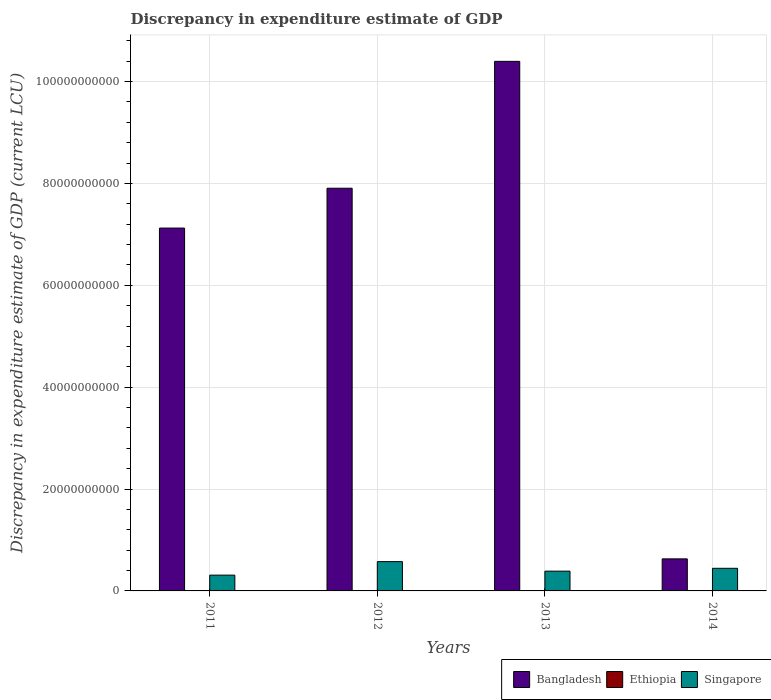How many different coloured bars are there?
Give a very brief answer. 3. How many groups of bars are there?
Make the answer very short. 4. Are the number of bars per tick equal to the number of legend labels?
Provide a short and direct response. No. Are the number of bars on each tick of the X-axis equal?
Provide a succinct answer. No. How many bars are there on the 2nd tick from the right?
Your answer should be compact. 2. What is the discrepancy in expenditure estimate of GDP in Bangladesh in 2012?
Give a very brief answer. 7.91e+1. Across all years, what is the maximum discrepancy in expenditure estimate of GDP in Singapore?
Offer a very short reply. 5.75e+09. Across all years, what is the minimum discrepancy in expenditure estimate of GDP in Bangladesh?
Provide a short and direct response. 6.29e+09. In which year was the discrepancy in expenditure estimate of GDP in Ethiopia maximum?
Make the answer very short. 2012. What is the total discrepancy in expenditure estimate of GDP in Bangladesh in the graph?
Ensure brevity in your answer.  2.61e+11. What is the difference between the discrepancy in expenditure estimate of GDP in Singapore in 2011 and that in 2013?
Make the answer very short. -7.83e+08. What is the difference between the discrepancy in expenditure estimate of GDP in Singapore in 2011 and the discrepancy in expenditure estimate of GDP in Bangladesh in 2014?
Offer a very short reply. -3.19e+09. What is the average discrepancy in expenditure estimate of GDP in Bangladesh per year?
Your answer should be compact. 6.51e+1. In the year 2013, what is the difference between the discrepancy in expenditure estimate of GDP in Bangladesh and discrepancy in expenditure estimate of GDP in Singapore?
Provide a short and direct response. 1.00e+11. In how many years, is the discrepancy in expenditure estimate of GDP in Ethiopia greater than 80000000000 LCU?
Offer a very short reply. 0. What is the ratio of the discrepancy in expenditure estimate of GDP in Bangladesh in 2011 to that in 2014?
Ensure brevity in your answer.  11.32. What is the difference between the highest and the second highest discrepancy in expenditure estimate of GDP in Singapore?
Your answer should be very brief. 1.31e+09. What is the difference between the highest and the lowest discrepancy in expenditure estimate of GDP in Singapore?
Ensure brevity in your answer.  2.65e+09. In how many years, is the discrepancy in expenditure estimate of GDP in Ethiopia greater than the average discrepancy in expenditure estimate of GDP in Ethiopia taken over all years?
Ensure brevity in your answer.  1. Is the sum of the discrepancy in expenditure estimate of GDP in Singapore in 2012 and 2013 greater than the maximum discrepancy in expenditure estimate of GDP in Ethiopia across all years?
Keep it short and to the point. Yes. How many years are there in the graph?
Provide a succinct answer. 4. Are the values on the major ticks of Y-axis written in scientific E-notation?
Offer a very short reply. No. Does the graph contain grids?
Provide a succinct answer. Yes. Where does the legend appear in the graph?
Make the answer very short. Bottom right. How are the legend labels stacked?
Your response must be concise. Horizontal. What is the title of the graph?
Provide a succinct answer. Discrepancy in expenditure estimate of GDP. Does "Algeria" appear as one of the legend labels in the graph?
Make the answer very short. No. What is the label or title of the Y-axis?
Your answer should be compact. Discrepancy in expenditure estimate of GDP (current LCU). What is the Discrepancy in expenditure estimate of GDP (current LCU) in Bangladesh in 2011?
Your answer should be very brief. 7.12e+1. What is the Discrepancy in expenditure estimate of GDP (current LCU) in Ethiopia in 2011?
Your answer should be compact. 0. What is the Discrepancy in expenditure estimate of GDP (current LCU) of Singapore in 2011?
Provide a short and direct response. 3.10e+09. What is the Discrepancy in expenditure estimate of GDP (current LCU) of Bangladesh in 2012?
Offer a very short reply. 7.91e+1. What is the Discrepancy in expenditure estimate of GDP (current LCU) of Ethiopia in 2012?
Offer a very short reply. 9.49e+04. What is the Discrepancy in expenditure estimate of GDP (current LCU) in Singapore in 2012?
Provide a succinct answer. 5.75e+09. What is the Discrepancy in expenditure estimate of GDP (current LCU) in Bangladesh in 2013?
Provide a short and direct response. 1.04e+11. What is the Discrepancy in expenditure estimate of GDP (current LCU) in Ethiopia in 2013?
Provide a short and direct response. 0. What is the Discrepancy in expenditure estimate of GDP (current LCU) in Singapore in 2013?
Ensure brevity in your answer.  3.88e+09. What is the Discrepancy in expenditure estimate of GDP (current LCU) in Bangladesh in 2014?
Make the answer very short. 6.29e+09. What is the Discrepancy in expenditure estimate of GDP (current LCU) of Singapore in 2014?
Your answer should be compact. 4.44e+09. Across all years, what is the maximum Discrepancy in expenditure estimate of GDP (current LCU) in Bangladesh?
Provide a succinct answer. 1.04e+11. Across all years, what is the maximum Discrepancy in expenditure estimate of GDP (current LCU) in Ethiopia?
Your answer should be very brief. 9.49e+04. Across all years, what is the maximum Discrepancy in expenditure estimate of GDP (current LCU) of Singapore?
Provide a succinct answer. 5.75e+09. Across all years, what is the minimum Discrepancy in expenditure estimate of GDP (current LCU) of Bangladesh?
Provide a succinct answer. 6.29e+09. Across all years, what is the minimum Discrepancy in expenditure estimate of GDP (current LCU) of Singapore?
Give a very brief answer. 3.10e+09. What is the total Discrepancy in expenditure estimate of GDP (current LCU) in Bangladesh in the graph?
Offer a very short reply. 2.61e+11. What is the total Discrepancy in expenditure estimate of GDP (current LCU) in Ethiopia in the graph?
Your response must be concise. 9.49e+04. What is the total Discrepancy in expenditure estimate of GDP (current LCU) in Singapore in the graph?
Give a very brief answer. 1.72e+1. What is the difference between the Discrepancy in expenditure estimate of GDP (current LCU) of Bangladesh in 2011 and that in 2012?
Ensure brevity in your answer.  -7.82e+09. What is the difference between the Discrepancy in expenditure estimate of GDP (current LCU) of Singapore in 2011 and that in 2012?
Your response must be concise. -2.65e+09. What is the difference between the Discrepancy in expenditure estimate of GDP (current LCU) of Bangladesh in 2011 and that in 2013?
Offer a terse response. -3.27e+1. What is the difference between the Discrepancy in expenditure estimate of GDP (current LCU) of Singapore in 2011 and that in 2013?
Your answer should be very brief. -7.83e+08. What is the difference between the Discrepancy in expenditure estimate of GDP (current LCU) of Bangladesh in 2011 and that in 2014?
Give a very brief answer. 6.49e+1. What is the difference between the Discrepancy in expenditure estimate of GDP (current LCU) in Singapore in 2011 and that in 2014?
Keep it short and to the point. -1.34e+09. What is the difference between the Discrepancy in expenditure estimate of GDP (current LCU) in Bangladesh in 2012 and that in 2013?
Your answer should be compact. -2.49e+1. What is the difference between the Discrepancy in expenditure estimate of GDP (current LCU) of Singapore in 2012 and that in 2013?
Offer a terse response. 1.87e+09. What is the difference between the Discrepancy in expenditure estimate of GDP (current LCU) in Bangladesh in 2012 and that in 2014?
Make the answer very short. 7.28e+1. What is the difference between the Discrepancy in expenditure estimate of GDP (current LCU) in Singapore in 2012 and that in 2014?
Make the answer very short. 1.31e+09. What is the difference between the Discrepancy in expenditure estimate of GDP (current LCU) in Bangladesh in 2013 and that in 2014?
Keep it short and to the point. 9.77e+1. What is the difference between the Discrepancy in expenditure estimate of GDP (current LCU) in Singapore in 2013 and that in 2014?
Offer a terse response. -5.59e+08. What is the difference between the Discrepancy in expenditure estimate of GDP (current LCU) in Bangladesh in 2011 and the Discrepancy in expenditure estimate of GDP (current LCU) in Ethiopia in 2012?
Ensure brevity in your answer.  7.12e+1. What is the difference between the Discrepancy in expenditure estimate of GDP (current LCU) of Bangladesh in 2011 and the Discrepancy in expenditure estimate of GDP (current LCU) of Singapore in 2012?
Offer a terse response. 6.55e+1. What is the difference between the Discrepancy in expenditure estimate of GDP (current LCU) in Bangladesh in 2011 and the Discrepancy in expenditure estimate of GDP (current LCU) in Singapore in 2013?
Your response must be concise. 6.74e+1. What is the difference between the Discrepancy in expenditure estimate of GDP (current LCU) in Bangladesh in 2011 and the Discrepancy in expenditure estimate of GDP (current LCU) in Singapore in 2014?
Your response must be concise. 6.68e+1. What is the difference between the Discrepancy in expenditure estimate of GDP (current LCU) of Bangladesh in 2012 and the Discrepancy in expenditure estimate of GDP (current LCU) of Singapore in 2013?
Offer a terse response. 7.52e+1. What is the difference between the Discrepancy in expenditure estimate of GDP (current LCU) of Ethiopia in 2012 and the Discrepancy in expenditure estimate of GDP (current LCU) of Singapore in 2013?
Make the answer very short. -3.88e+09. What is the difference between the Discrepancy in expenditure estimate of GDP (current LCU) of Bangladesh in 2012 and the Discrepancy in expenditure estimate of GDP (current LCU) of Singapore in 2014?
Ensure brevity in your answer.  7.46e+1. What is the difference between the Discrepancy in expenditure estimate of GDP (current LCU) of Ethiopia in 2012 and the Discrepancy in expenditure estimate of GDP (current LCU) of Singapore in 2014?
Make the answer very short. -4.44e+09. What is the difference between the Discrepancy in expenditure estimate of GDP (current LCU) of Bangladesh in 2013 and the Discrepancy in expenditure estimate of GDP (current LCU) of Singapore in 2014?
Your answer should be very brief. 9.95e+1. What is the average Discrepancy in expenditure estimate of GDP (current LCU) of Bangladesh per year?
Offer a terse response. 6.51e+1. What is the average Discrepancy in expenditure estimate of GDP (current LCU) of Ethiopia per year?
Keep it short and to the point. 2.37e+04. What is the average Discrepancy in expenditure estimate of GDP (current LCU) in Singapore per year?
Provide a succinct answer. 4.29e+09. In the year 2011, what is the difference between the Discrepancy in expenditure estimate of GDP (current LCU) of Bangladesh and Discrepancy in expenditure estimate of GDP (current LCU) of Singapore?
Provide a short and direct response. 6.81e+1. In the year 2012, what is the difference between the Discrepancy in expenditure estimate of GDP (current LCU) in Bangladesh and Discrepancy in expenditure estimate of GDP (current LCU) in Ethiopia?
Provide a short and direct response. 7.91e+1. In the year 2012, what is the difference between the Discrepancy in expenditure estimate of GDP (current LCU) in Bangladesh and Discrepancy in expenditure estimate of GDP (current LCU) in Singapore?
Offer a very short reply. 7.33e+1. In the year 2012, what is the difference between the Discrepancy in expenditure estimate of GDP (current LCU) in Ethiopia and Discrepancy in expenditure estimate of GDP (current LCU) in Singapore?
Make the answer very short. -5.75e+09. In the year 2013, what is the difference between the Discrepancy in expenditure estimate of GDP (current LCU) of Bangladesh and Discrepancy in expenditure estimate of GDP (current LCU) of Singapore?
Your response must be concise. 1.00e+11. In the year 2014, what is the difference between the Discrepancy in expenditure estimate of GDP (current LCU) of Bangladesh and Discrepancy in expenditure estimate of GDP (current LCU) of Singapore?
Make the answer very short. 1.85e+09. What is the ratio of the Discrepancy in expenditure estimate of GDP (current LCU) in Bangladesh in 2011 to that in 2012?
Keep it short and to the point. 0.9. What is the ratio of the Discrepancy in expenditure estimate of GDP (current LCU) in Singapore in 2011 to that in 2012?
Ensure brevity in your answer.  0.54. What is the ratio of the Discrepancy in expenditure estimate of GDP (current LCU) in Bangladesh in 2011 to that in 2013?
Make the answer very short. 0.69. What is the ratio of the Discrepancy in expenditure estimate of GDP (current LCU) in Singapore in 2011 to that in 2013?
Make the answer very short. 0.8. What is the ratio of the Discrepancy in expenditure estimate of GDP (current LCU) in Bangladesh in 2011 to that in 2014?
Keep it short and to the point. 11.32. What is the ratio of the Discrepancy in expenditure estimate of GDP (current LCU) in Singapore in 2011 to that in 2014?
Give a very brief answer. 0.7. What is the ratio of the Discrepancy in expenditure estimate of GDP (current LCU) of Bangladesh in 2012 to that in 2013?
Offer a very short reply. 0.76. What is the ratio of the Discrepancy in expenditure estimate of GDP (current LCU) in Singapore in 2012 to that in 2013?
Provide a short and direct response. 1.48. What is the ratio of the Discrepancy in expenditure estimate of GDP (current LCU) in Bangladesh in 2012 to that in 2014?
Give a very brief answer. 12.56. What is the ratio of the Discrepancy in expenditure estimate of GDP (current LCU) in Singapore in 2012 to that in 2014?
Offer a terse response. 1.3. What is the ratio of the Discrepancy in expenditure estimate of GDP (current LCU) in Bangladesh in 2013 to that in 2014?
Offer a very short reply. 16.52. What is the ratio of the Discrepancy in expenditure estimate of GDP (current LCU) of Singapore in 2013 to that in 2014?
Make the answer very short. 0.87. What is the difference between the highest and the second highest Discrepancy in expenditure estimate of GDP (current LCU) of Bangladesh?
Ensure brevity in your answer.  2.49e+1. What is the difference between the highest and the second highest Discrepancy in expenditure estimate of GDP (current LCU) of Singapore?
Offer a terse response. 1.31e+09. What is the difference between the highest and the lowest Discrepancy in expenditure estimate of GDP (current LCU) of Bangladesh?
Offer a terse response. 9.77e+1. What is the difference between the highest and the lowest Discrepancy in expenditure estimate of GDP (current LCU) of Ethiopia?
Offer a terse response. 9.49e+04. What is the difference between the highest and the lowest Discrepancy in expenditure estimate of GDP (current LCU) of Singapore?
Keep it short and to the point. 2.65e+09. 